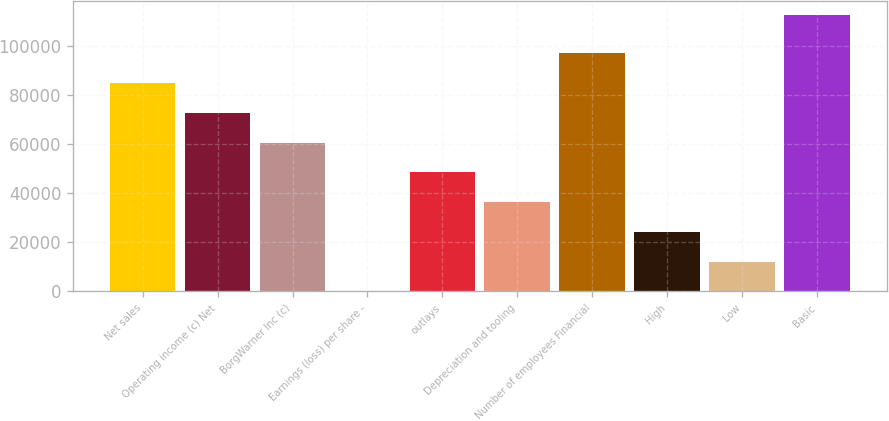Convert chart. <chart><loc_0><loc_0><loc_500><loc_500><bar_chart><fcel>Net sales<fcel>Operating income (c) Net<fcel>BorgWarner Inc (c)<fcel>Earnings (loss) per share -<fcel>outlays<fcel>Depreciation and tooling<fcel>Number of employees Financial<fcel>High<fcel>Low<fcel>Basic<nl><fcel>84965.2<fcel>72828<fcel>60690.7<fcel>4.45<fcel>48553.5<fcel>36416.2<fcel>97102.5<fcel>24279<fcel>12141.7<fcel>112652<nl></chart> 